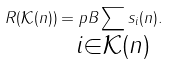<formula> <loc_0><loc_0><loc_500><loc_500>R ( \mathcal { K } ( n ) ) = p B \sum _ { \mathclap { i \in \mathcal { K } ( n ) } } s _ { i } ( n ) .</formula> 